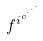Convert formula to latex. <formula><loc_0><loc_0><loc_500><loc_500>f ^ { i ^ { c ^ { \cdot ^ { \cdot ^ { \cdot } } } } }</formula> 